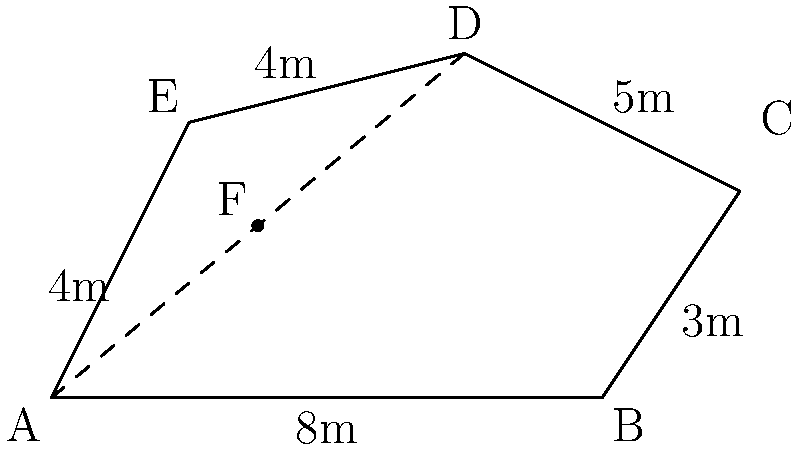For a new TV drama series, you need to compose music for a scene set on an irregularly shaped stage. The stage's shape is represented by the polygon ABCDE in the diagram. If AB = 8m, BC = 3m, CD = 5m, DE = 4m, and EA = 4m, what is the area of the stage in square meters? To find the area of this irregular polygon, we can divide it into simpler shapes:

1) First, draw a diagonal from A to D, creating two triangles: ADE and ABCD.

2) For triangle ADE:
   Base (AE) = 4m, Height (perpendicular from D to AE) can be found using Pythagorean theorem:
   $$(DE)^2 = (AE)^2 + h^2$$
   $4^2 = 4^2 + h^2$
   $h = \sqrt{16 - 16} = 0$
   Area of ADE = $\frac{1}{2} \times 4 \times 0 = 0$ (This triangle is actually a line)

3) For quadrilateral ABCD:
   We can divide this into two triangles: ABC and ACD
   
   For ABC:
   Base (AB) = 8m, Height (perpendicular from C to AB) = 3m
   Area of ABC = $\frac{1}{2} \times 8 \times 3 = 12$ sq m

   For ACD:
   We need to find the height (perpendicular from C to AD)
   Let's call the point where this perpendicular meets AD as F
   AF = $\frac{AD}{2} = \frac{\sqrt{8^2 + 5^2}}{2} = \frac{\sqrt{89}}{2}$
   
   In right triangle CFD:
   $CF^2 + (\frac{\sqrt{89}}{2})^2 = 5^2$
   $CF^2 = 25 - \frac{89}{4} = \frac{11}{4}$
   $CF = \frac{\sqrt{11}}{2}$

   Area of ACD = $\frac{1}{2} \times \sqrt{89} \times \frac{\sqrt{11}}{2} = \frac{\sqrt{979}}{4}$ sq m

4) Total area = Area of ABC + Area of ACD
               $= 12 + \frac{\sqrt{979}}{4}$ sq m
               $= \frac{48 + \sqrt{979}}{4}$ sq m
Answer: $\frac{48 + \sqrt{979}}{4}$ sq m 